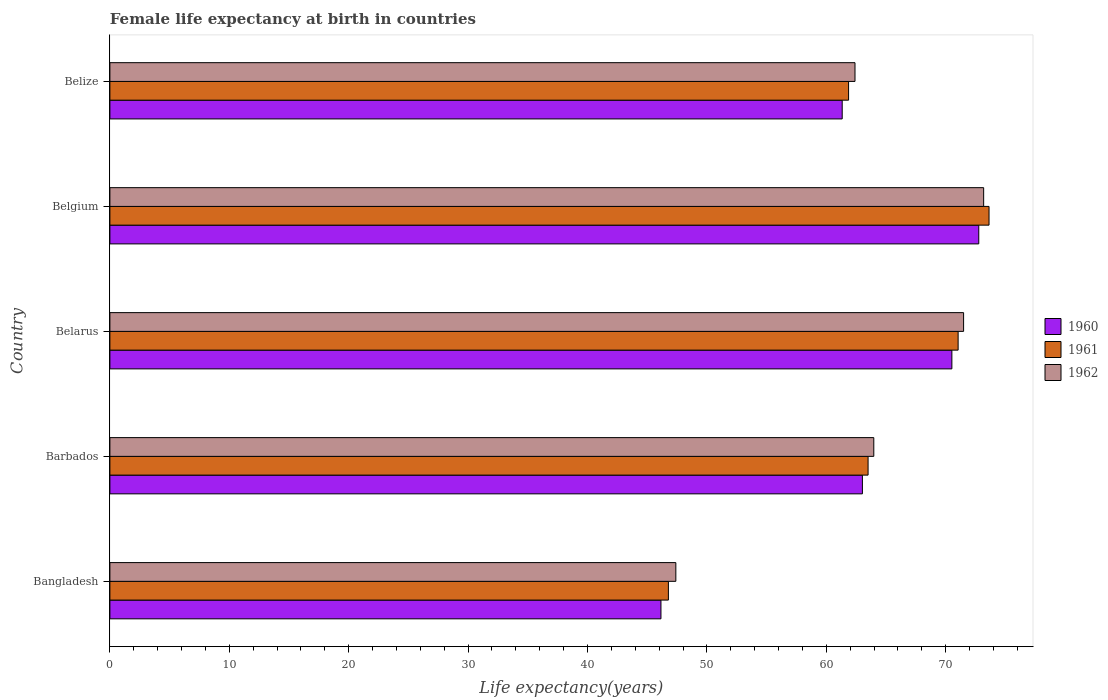How many different coloured bars are there?
Offer a terse response. 3. How many groups of bars are there?
Your response must be concise. 5. Are the number of bars on each tick of the Y-axis equal?
Keep it short and to the point. Yes. In how many cases, is the number of bars for a given country not equal to the number of legend labels?
Provide a succinct answer. 0. What is the female life expectancy at birth in 1962 in Barbados?
Your response must be concise. 63.98. Across all countries, what is the maximum female life expectancy at birth in 1961?
Provide a short and direct response. 73.63. Across all countries, what is the minimum female life expectancy at birth in 1961?
Provide a short and direct response. 46.78. In which country was the female life expectancy at birth in 1962 maximum?
Ensure brevity in your answer.  Belgium. In which country was the female life expectancy at birth in 1961 minimum?
Your answer should be very brief. Bangladesh. What is the total female life expectancy at birth in 1961 in the graph?
Offer a very short reply. 316.81. What is the difference between the female life expectancy at birth in 1961 in Belarus and that in Belize?
Your answer should be compact. 9.17. What is the difference between the female life expectancy at birth in 1962 in Bangladesh and the female life expectancy at birth in 1961 in Barbados?
Provide a succinct answer. -16.1. What is the average female life expectancy at birth in 1962 per country?
Keep it short and to the point. 63.69. What is the difference between the female life expectancy at birth in 1960 and female life expectancy at birth in 1962 in Barbados?
Your answer should be compact. -0.95. What is the ratio of the female life expectancy at birth in 1961 in Belarus to that in Belgium?
Keep it short and to the point. 0.96. Is the difference between the female life expectancy at birth in 1960 in Bangladesh and Belgium greater than the difference between the female life expectancy at birth in 1962 in Bangladesh and Belgium?
Provide a short and direct response. No. What is the difference between the highest and the second highest female life expectancy at birth in 1962?
Your answer should be very brief. 1.68. What is the difference between the highest and the lowest female life expectancy at birth in 1960?
Make the answer very short. 26.62. In how many countries, is the female life expectancy at birth in 1961 greater than the average female life expectancy at birth in 1961 taken over all countries?
Provide a short and direct response. 3. Is the sum of the female life expectancy at birth in 1962 in Bangladesh and Belgium greater than the maximum female life expectancy at birth in 1960 across all countries?
Provide a short and direct response. Yes. What does the 2nd bar from the top in Bangladesh represents?
Offer a very short reply. 1961. How many bars are there?
Your response must be concise. 15. How many countries are there in the graph?
Give a very brief answer. 5. What is the difference between two consecutive major ticks on the X-axis?
Offer a very short reply. 10. Are the values on the major ticks of X-axis written in scientific E-notation?
Keep it short and to the point. No. What is the title of the graph?
Your answer should be very brief. Female life expectancy at birth in countries. Does "1998" appear as one of the legend labels in the graph?
Give a very brief answer. No. What is the label or title of the X-axis?
Ensure brevity in your answer.  Life expectancy(years). What is the Life expectancy(years) of 1960 in Bangladesh?
Offer a terse response. 46.15. What is the Life expectancy(years) in 1961 in Bangladesh?
Offer a terse response. 46.78. What is the Life expectancy(years) in 1962 in Bangladesh?
Provide a succinct answer. 47.4. What is the Life expectancy(years) of 1960 in Barbados?
Ensure brevity in your answer.  63.02. What is the Life expectancy(years) in 1961 in Barbados?
Your answer should be very brief. 63.5. What is the Life expectancy(years) in 1962 in Barbados?
Keep it short and to the point. 63.98. What is the Life expectancy(years) of 1960 in Belarus?
Your answer should be compact. 70.52. What is the Life expectancy(years) in 1961 in Belarus?
Offer a terse response. 71.04. What is the Life expectancy(years) of 1962 in Belarus?
Provide a succinct answer. 71.5. What is the Life expectancy(years) of 1960 in Belgium?
Offer a very short reply. 72.77. What is the Life expectancy(years) of 1961 in Belgium?
Make the answer very short. 73.63. What is the Life expectancy(years) of 1962 in Belgium?
Your response must be concise. 73.18. What is the Life expectancy(years) of 1960 in Belize?
Keep it short and to the point. 61.33. What is the Life expectancy(years) in 1961 in Belize?
Make the answer very short. 61.87. What is the Life expectancy(years) in 1962 in Belize?
Give a very brief answer. 62.4. Across all countries, what is the maximum Life expectancy(years) of 1960?
Offer a terse response. 72.77. Across all countries, what is the maximum Life expectancy(years) in 1961?
Your response must be concise. 73.63. Across all countries, what is the maximum Life expectancy(years) of 1962?
Your response must be concise. 73.18. Across all countries, what is the minimum Life expectancy(years) in 1960?
Your answer should be compact. 46.15. Across all countries, what is the minimum Life expectancy(years) of 1961?
Provide a short and direct response. 46.78. Across all countries, what is the minimum Life expectancy(years) in 1962?
Your response must be concise. 47.4. What is the total Life expectancy(years) in 1960 in the graph?
Give a very brief answer. 313.8. What is the total Life expectancy(years) of 1961 in the graph?
Your answer should be very brief. 316.81. What is the total Life expectancy(years) in 1962 in the graph?
Offer a terse response. 318.46. What is the difference between the Life expectancy(years) in 1960 in Bangladesh and that in Barbados?
Your response must be concise. -16.87. What is the difference between the Life expectancy(years) of 1961 in Bangladesh and that in Barbados?
Your answer should be compact. -16.72. What is the difference between the Life expectancy(years) of 1962 in Bangladesh and that in Barbados?
Ensure brevity in your answer.  -16.58. What is the difference between the Life expectancy(years) in 1960 in Bangladesh and that in Belarus?
Provide a short and direct response. -24.37. What is the difference between the Life expectancy(years) in 1961 in Bangladesh and that in Belarus?
Give a very brief answer. -24.27. What is the difference between the Life expectancy(years) of 1962 in Bangladesh and that in Belarus?
Your response must be concise. -24.1. What is the difference between the Life expectancy(years) in 1960 in Bangladesh and that in Belgium?
Ensure brevity in your answer.  -26.62. What is the difference between the Life expectancy(years) in 1961 in Bangladesh and that in Belgium?
Provide a succinct answer. -26.85. What is the difference between the Life expectancy(years) of 1962 in Bangladesh and that in Belgium?
Your answer should be compact. -25.78. What is the difference between the Life expectancy(years) of 1960 in Bangladesh and that in Belize?
Provide a short and direct response. -15.18. What is the difference between the Life expectancy(years) of 1961 in Bangladesh and that in Belize?
Your answer should be compact. -15.09. What is the difference between the Life expectancy(years) of 1962 in Bangladesh and that in Belize?
Keep it short and to the point. -15. What is the difference between the Life expectancy(years) in 1960 in Barbados and that in Belarus?
Ensure brevity in your answer.  -7.49. What is the difference between the Life expectancy(years) in 1961 in Barbados and that in Belarus?
Your answer should be very brief. -7.54. What is the difference between the Life expectancy(years) of 1962 in Barbados and that in Belarus?
Your response must be concise. -7.52. What is the difference between the Life expectancy(years) in 1960 in Barbados and that in Belgium?
Make the answer very short. -9.74. What is the difference between the Life expectancy(years) of 1961 in Barbados and that in Belgium?
Your answer should be compact. -10.13. What is the difference between the Life expectancy(years) in 1962 in Barbados and that in Belgium?
Provide a short and direct response. -9.2. What is the difference between the Life expectancy(years) in 1960 in Barbados and that in Belize?
Offer a terse response. 1.69. What is the difference between the Life expectancy(years) in 1961 in Barbados and that in Belize?
Provide a succinct answer. 1.63. What is the difference between the Life expectancy(years) in 1962 in Barbados and that in Belize?
Your answer should be very brief. 1.57. What is the difference between the Life expectancy(years) in 1960 in Belarus and that in Belgium?
Provide a short and direct response. -2.25. What is the difference between the Life expectancy(years) of 1961 in Belarus and that in Belgium?
Provide a short and direct response. -2.59. What is the difference between the Life expectancy(years) of 1962 in Belarus and that in Belgium?
Offer a terse response. -1.68. What is the difference between the Life expectancy(years) in 1960 in Belarus and that in Belize?
Your answer should be very brief. 9.19. What is the difference between the Life expectancy(years) of 1961 in Belarus and that in Belize?
Your response must be concise. 9.18. What is the difference between the Life expectancy(years) of 1962 in Belarus and that in Belize?
Provide a succinct answer. 9.1. What is the difference between the Life expectancy(years) of 1960 in Belgium and that in Belize?
Provide a succinct answer. 11.44. What is the difference between the Life expectancy(years) in 1961 in Belgium and that in Belize?
Your answer should be very brief. 11.76. What is the difference between the Life expectancy(years) in 1962 in Belgium and that in Belize?
Ensure brevity in your answer.  10.78. What is the difference between the Life expectancy(years) of 1960 in Bangladesh and the Life expectancy(years) of 1961 in Barbados?
Offer a very short reply. -17.35. What is the difference between the Life expectancy(years) of 1960 in Bangladesh and the Life expectancy(years) of 1962 in Barbados?
Offer a very short reply. -17.83. What is the difference between the Life expectancy(years) in 1961 in Bangladesh and the Life expectancy(years) in 1962 in Barbados?
Offer a very short reply. -17.2. What is the difference between the Life expectancy(years) of 1960 in Bangladesh and the Life expectancy(years) of 1961 in Belarus?
Offer a terse response. -24.89. What is the difference between the Life expectancy(years) in 1960 in Bangladesh and the Life expectancy(years) in 1962 in Belarus?
Keep it short and to the point. -25.35. What is the difference between the Life expectancy(years) in 1961 in Bangladesh and the Life expectancy(years) in 1962 in Belarus?
Your response must be concise. -24.72. What is the difference between the Life expectancy(years) of 1960 in Bangladesh and the Life expectancy(years) of 1961 in Belgium?
Your answer should be very brief. -27.48. What is the difference between the Life expectancy(years) in 1960 in Bangladesh and the Life expectancy(years) in 1962 in Belgium?
Provide a short and direct response. -27.03. What is the difference between the Life expectancy(years) of 1961 in Bangladesh and the Life expectancy(years) of 1962 in Belgium?
Provide a succinct answer. -26.4. What is the difference between the Life expectancy(years) in 1960 in Bangladesh and the Life expectancy(years) in 1961 in Belize?
Your answer should be compact. -15.71. What is the difference between the Life expectancy(years) of 1960 in Bangladesh and the Life expectancy(years) of 1962 in Belize?
Make the answer very short. -16.25. What is the difference between the Life expectancy(years) in 1961 in Bangladesh and the Life expectancy(years) in 1962 in Belize?
Offer a terse response. -15.63. What is the difference between the Life expectancy(years) of 1960 in Barbados and the Life expectancy(years) of 1961 in Belarus?
Your answer should be very brief. -8.02. What is the difference between the Life expectancy(years) in 1960 in Barbados and the Life expectancy(years) in 1962 in Belarus?
Ensure brevity in your answer.  -8.47. What is the difference between the Life expectancy(years) of 1961 in Barbados and the Life expectancy(years) of 1962 in Belarus?
Provide a short and direct response. -8. What is the difference between the Life expectancy(years) in 1960 in Barbados and the Life expectancy(years) in 1961 in Belgium?
Your response must be concise. -10.61. What is the difference between the Life expectancy(years) of 1960 in Barbados and the Life expectancy(years) of 1962 in Belgium?
Offer a terse response. -10.15. What is the difference between the Life expectancy(years) in 1961 in Barbados and the Life expectancy(years) in 1962 in Belgium?
Provide a succinct answer. -9.68. What is the difference between the Life expectancy(years) in 1960 in Barbados and the Life expectancy(years) in 1961 in Belize?
Make the answer very short. 1.16. What is the difference between the Life expectancy(years) in 1960 in Barbados and the Life expectancy(years) in 1962 in Belize?
Ensure brevity in your answer.  0.62. What is the difference between the Life expectancy(years) in 1961 in Barbados and the Life expectancy(years) in 1962 in Belize?
Your answer should be very brief. 1.1. What is the difference between the Life expectancy(years) of 1960 in Belarus and the Life expectancy(years) of 1961 in Belgium?
Provide a succinct answer. -3.11. What is the difference between the Life expectancy(years) of 1960 in Belarus and the Life expectancy(years) of 1962 in Belgium?
Offer a very short reply. -2.66. What is the difference between the Life expectancy(years) in 1961 in Belarus and the Life expectancy(years) in 1962 in Belgium?
Offer a very short reply. -2.14. What is the difference between the Life expectancy(years) in 1960 in Belarus and the Life expectancy(years) in 1961 in Belize?
Make the answer very short. 8.65. What is the difference between the Life expectancy(years) of 1960 in Belarus and the Life expectancy(years) of 1962 in Belize?
Offer a terse response. 8.11. What is the difference between the Life expectancy(years) in 1961 in Belarus and the Life expectancy(years) in 1962 in Belize?
Keep it short and to the point. 8.64. What is the difference between the Life expectancy(years) in 1960 in Belgium and the Life expectancy(years) in 1961 in Belize?
Offer a very short reply. 10.9. What is the difference between the Life expectancy(years) in 1960 in Belgium and the Life expectancy(years) in 1962 in Belize?
Offer a very short reply. 10.37. What is the difference between the Life expectancy(years) of 1961 in Belgium and the Life expectancy(years) of 1962 in Belize?
Make the answer very short. 11.23. What is the average Life expectancy(years) of 1960 per country?
Offer a very short reply. 62.76. What is the average Life expectancy(years) of 1961 per country?
Provide a succinct answer. 63.36. What is the average Life expectancy(years) of 1962 per country?
Provide a succinct answer. 63.69. What is the difference between the Life expectancy(years) in 1960 and Life expectancy(years) in 1961 in Bangladesh?
Ensure brevity in your answer.  -0.62. What is the difference between the Life expectancy(years) of 1960 and Life expectancy(years) of 1962 in Bangladesh?
Ensure brevity in your answer.  -1.25. What is the difference between the Life expectancy(years) in 1961 and Life expectancy(years) in 1962 in Bangladesh?
Your answer should be compact. -0.62. What is the difference between the Life expectancy(years) in 1960 and Life expectancy(years) in 1961 in Barbados?
Make the answer very short. -0.47. What is the difference between the Life expectancy(years) in 1960 and Life expectancy(years) in 1962 in Barbados?
Make the answer very short. -0.95. What is the difference between the Life expectancy(years) in 1961 and Life expectancy(years) in 1962 in Barbados?
Offer a very short reply. -0.48. What is the difference between the Life expectancy(years) in 1960 and Life expectancy(years) in 1961 in Belarus?
Your answer should be very brief. -0.52. What is the difference between the Life expectancy(years) of 1960 and Life expectancy(years) of 1962 in Belarus?
Make the answer very short. -0.98. What is the difference between the Life expectancy(years) of 1961 and Life expectancy(years) of 1962 in Belarus?
Ensure brevity in your answer.  -0.46. What is the difference between the Life expectancy(years) in 1960 and Life expectancy(years) in 1961 in Belgium?
Give a very brief answer. -0.86. What is the difference between the Life expectancy(years) in 1960 and Life expectancy(years) in 1962 in Belgium?
Provide a short and direct response. -0.41. What is the difference between the Life expectancy(years) of 1961 and Life expectancy(years) of 1962 in Belgium?
Your answer should be compact. 0.45. What is the difference between the Life expectancy(years) in 1960 and Life expectancy(years) in 1961 in Belize?
Ensure brevity in your answer.  -0.53. What is the difference between the Life expectancy(years) in 1960 and Life expectancy(years) in 1962 in Belize?
Your answer should be compact. -1.07. What is the difference between the Life expectancy(years) of 1961 and Life expectancy(years) of 1962 in Belize?
Your answer should be very brief. -0.54. What is the ratio of the Life expectancy(years) of 1960 in Bangladesh to that in Barbados?
Your answer should be very brief. 0.73. What is the ratio of the Life expectancy(years) of 1961 in Bangladesh to that in Barbados?
Your answer should be compact. 0.74. What is the ratio of the Life expectancy(years) in 1962 in Bangladesh to that in Barbados?
Provide a short and direct response. 0.74. What is the ratio of the Life expectancy(years) in 1960 in Bangladesh to that in Belarus?
Keep it short and to the point. 0.65. What is the ratio of the Life expectancy(years) of 1961 in Bangladesh to that in Belarus?
Ensure brevity in your answer.  0.66. What is the ratio of the Life expectancy(years) of 1962 in Bangladesh to that in Belarus?
Your response must be concise. 0.66. What is the ratio of the Life expectancy(years) in 1960 in Bangladesh to that in Belgium?
Offer a terse response. 0.63. What is the ratio of the Life expectancy(years) of 1961 in Bangladesh to that in Belgium?
Make the answer very short. 0.64. What is the ratio of the Life expectancy(years) of 1962 in Bangladesh to that in Belgium?
Provide a succinct answer. 0.65. What is the ratio of the Life expectancy(years) in 1960 in Bangladesh to that in Belize?
Give a very brief answer. 0.75. What is the ratio of the Life expectancy(years) of 1961 in Bangladesh to that in Belize?
Your response must be concise. 0.76. What is the ratio of the Life expectancy(years) of 1962 in Bangladesh to that in Belize?
Give a very brief answer. 0.76. What is the ratio of the Life expectancy(years) in 1960 in Barbados to that in Belarus?
Ensure brevity in your answer.  0.89. What is the ratio of the Life expectancy(years) of 1961 in Barbados to that in Belarus?
Your answer should be very brief. 0.89. What is the ratio of the Life expectancy(years) in 1962 in Barbados to that in Belarus?
Provide a succinct answer. 0.89. What is the ratio of the Life expectancy(years) of 1960 in Barbados to that in Belgium?
Your response must be concise. 0.87. What is the ratio of the Life expectancy(years) of 1961 in Barbados to that in Belgium?
Provide a succinct answer. 0.86. What is the ratio of the Life expectancy(years) of 1962 in Barbados to that in Belgium?
Provide a succinct answer. 0.87. What is the ratio of the Life expectancy(years) in 1960 in Barbados to that in Belize?
Your answer should be compact. 1.03. What is the ratio of the Life expectancy(years) in 1961 in Barbados to that in Belize?
Give a very brief answer. 1.03. What is the ratio of the Life expectancy(years) of 1962 in Barbados to that in Belize?
Your answer should be very brief. 1.03. What is the ratio of the Life expectancy(years) in 1960 in Belarus to that in Belgium?
Offer a very short reply. 0.97. What is the ratio of the Life expectancy(years) of 1961 in Belarus to that in Belgium?
Provide a short and direct response. 0.96. What is the ratio of the Life expectancy(years) in 1960 in Belarus to that in Belize?
Your response must be concise. 1.15. What is the ratio of the Life expectancy(years) in 1961 in Belarus to that in Belize?
Provide a short and direct response. 1.15. What is the ratio of the Life expectancy(years) in 1962 in Belarus to that in Belize?
Keep it short and to the point. 1.15. What is the ratio of the Life expectancy(years) of 1960 in Belgium to that in Belize?
Ensure brevity in your answer.  1.19. What is the ratio of the Life expectancy(years) of 1961 in Belgium to that in Belize?
Offer a terse response. 1.19. What is the ratio of the Life expectancy(years) in 1962 in Belgium to that in Belize?
Your answer should be very brief. 1.17. What is the difference between the highest and the second highest Life expectancy(years) in 1960?
Offer a terse response. 2.25. What is the difference between the highest and the second highest Life expectancy(years) of 1961?
Keep it short and to the point. 2.59. What is the difference between the highest and the second highest Life expectancy(years) in 1962?
Keep it short and to the point. 1.68. What is the difference between the highest and the lowest Life expectancy(years) in 1960?
Make the answer very short. 26.62. What is the difference between the highest and the lowest Life expectancy(years) in 1961?
Keep it short and to the point. 26.85. What is the difference between the highest and the lowest Life expectancy(years) of 1962?
Your answer should be very brief. 25.78. 